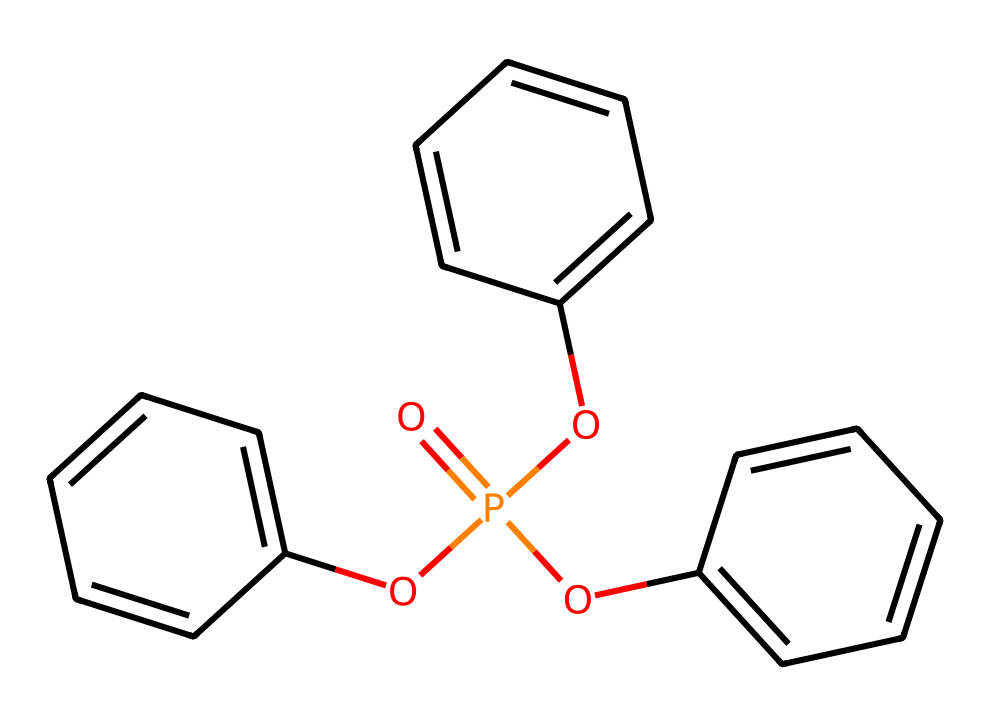What is the molecular formula of triphenyl phosphate? The SMILES representation indicates that triphenyl phosphate consists of phosphorus (P), oxygen (O), and hydrogen (H) atoms along with three phenyl groups (C6H5). Counting the atoms present, we find 3 phenyl groups contribute 18 carbon (C) and 15 hydrogen (H) atoms, plus 1 phosphorus (P) and 4 oxygen (O) atoms from the phosphate group. This gives us the molecular formula C18H15O4P.
Answer: C18H15O4P How many phenyl groups are attached to the phosphorus atom? The SMILES structure shows the phosphorus atom is connected to three separate phenyl groups (as indicated by the three "Oc" connections). Each "Oc" represents a phenyl group attached via an oxygen atom to the phosphorus.
Answer: three What is the oxidation state of phosphorus in this compound? The oxidation state of phosphorus can be determined by recognizing that in phosphates, phosphorus typically has an oxidation state of +5 when bonded to three oxygen atoms and involved in other bonds. Here, phosphorus is connected to four oxygen atoms total with one of them being double bonded (indicating an oxidation state of +5).
Answer: +5 What type of functional groups are present in triphenyl phosphate? In this molecule, the main functional group is the phosphate group (represented by O=P(O)(O)(O)), which includes oxygen and phosphorus. The phenyl groups attached through oxygen also imply the presence of ether-like characteristics. Hence, the primary functional group is phosphate.
Answer: phosphate What property is enhanced by the presence of triphenyl phosphate in art materials? The presence of triphenyl phosphate in art materials primarily enhances fire resistance as it acts as a flame retardant. This functional aspect is crucial especially in materials used for preservation and restoration projects.
Answer: fire resistance Which atom is at the center of the triphenyl phosphate structure? The central atom of triphenyl phosphate is phosphorus (P), as it is the core atom bonded to the three phenyl groups through oxygen atoms. By examining its placement in the SMILES, it is clear that phosphorus is the central element.
Answer: phosphorus 